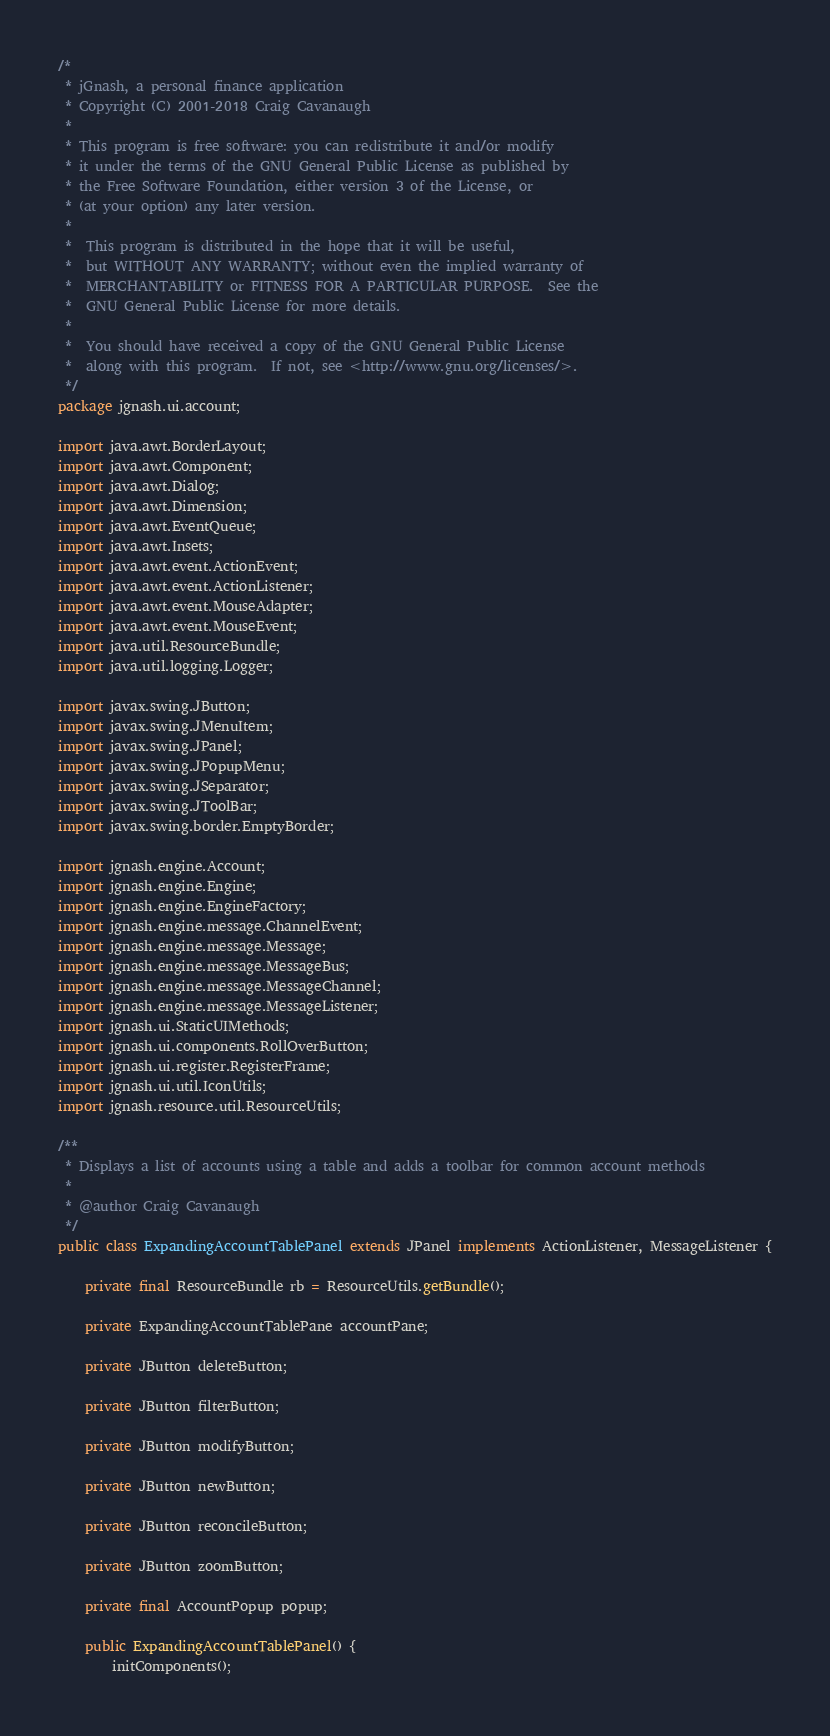Convert code to text. <code><loc_0><loc_0><loc_500><loc_500><_Java_>/*
 * jGnash, a personal finance application
 * Copyright (C) 2001-2018 Craig Cavanaugh
 *
 * This program is free software: you can redistribute it and/or modify
 * it under the terms of the GNU General Public License as published by
 * the Free Software Foundation, either version 3 of the License, or
 * (at your option) any later version.
 *
 *  This program is distributed in the hope that it will be useful,
 *  but WITHOUT ANY WARRANTY; without even the implied warranty of
 *  MERCHANTABILITY or FITNESS FOR A PARTICULAR PURPOSE.  See the
 *  GNU General Public License for more details.
 *
 *  You should have received a copy of the GNU General Public License
 *  along with this program.  If not, see <http://www.gnu.org/licenses/>.
 */
package jgnash.ui.account;

import java.awt.BorderLayout;
import java.awt.Component;
import java.awt.Dialog;
import java.awt.Dimension;
import java.awt.EventQueue;
import java.awt.Insets;
import java.awt.event.ActionEvent;
import java.awt.event.ActionListener;
import java.awt.event.MouseAdapter;
import java.awt.event.MouseEvent;
import java.util.ResourceBundle;
import java.util.logging.Logger;

import javax.swing.JButton;
import javax.swing.JMenuItem;
import javax.swing.JPanel;
import javax.swing.JPopupMenu;
import javax.swing.JSeparator;
import javax.swing.JToolBar;
import javax.swing.border.EmptyBorder;

import jgnash.engine.Account;
import jgnash.engine.Engine;
import jgnash.engine.EngineFactory;
import jgnash.engine.message.ChannelEvent;
import jgnash.engine.message.Message;
import jgnash.engine.message.MessageBus;
import jgnash.engine.message.MessageChannel;
import jgnash.engine.message.MessageListener;
import jgnash.ui.StaticUIMethods;
import jgnash.ui.components.RollOverButton;
import jgnash.ui.register.RegisterFrame;
import jgnash.ui.util.IconUtils;
import jgnash.resource.util.ResourceUtils;

/**
 * Displays a list of accounts using a table and adds a toolbar for common account methods
 * 
 * @author Craig Cavanaugh
 */
public class ExpandingAccountTablePanel extends JPanel implements ActionListener, MessageListener {

    private final ResourceBundle rb = ResourceUtils.getBundle();

    private ExpandingAccountTablePane accountPane;

    private JButton deleteButton;

    private JButton filterButton;

    private JButton modifyButton;

    private JButton newButton;

    private JButton reconcileButton;

    private JButton zoomButton;

    private final AccountPopup popup;

    public ExpandingAccountTablePanel() {
        initComponents();
</code> 